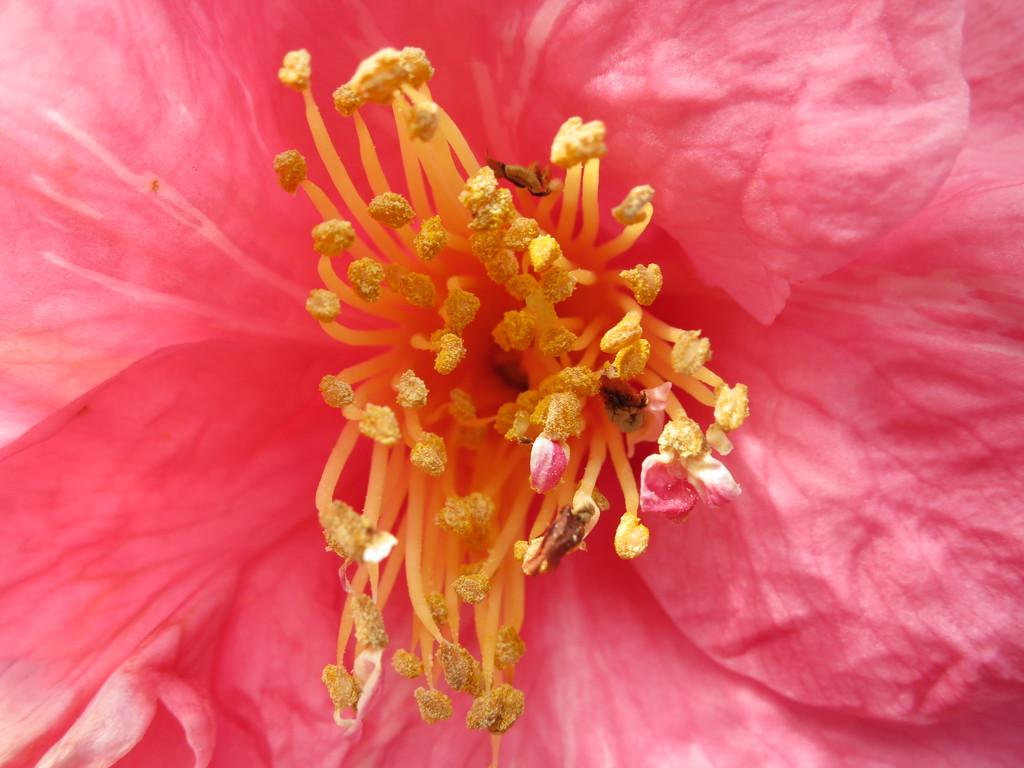What color is the flower in the image? The flower in the image is pink. What can be found in the center of the flower? The flower has a stigma in the middle. What flavor of ice cream do the girls enjoy with the hammer in the image? There are no girls, ice cream, or hammer present in the image; it only features a pink flower with a stigma in the middle. 